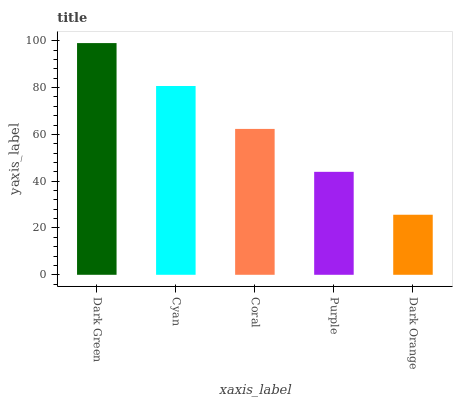Is Dark Orange the minimum?
Answer yes or no. Yes. Is Dark Green the maximum?
Answer yes or no. Yes. Is Cyan the minimum?
Answer yes or no. No. Is Cyan the maximum?
Answer yes or no. No. Is Dark Green greater than Cyan?
Answer yes or no. Yes. Is Cyan less than Dark Green?
Answer yes or no. Yes. Is Cyan greater than Dark Green?
Answer yes or no. No. Is Dark Green less than Cyan?
Answer yes or no. No. Is Coral the high median?
Answer yes or no. Yes. Is Coral the low median?
Answer yes or no. Yes. Is Purple the high median?
Answer yes or no. No. Is Dark Orange the low median?
Answer yes or no. No. 